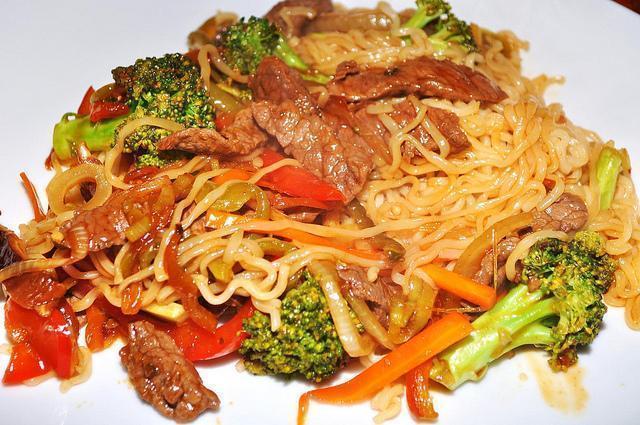What is touching the broccoli?
Choose the correct response, then elucidate: 'Answer: answer
Rationale: rationale.'
Options: Cats paw, pasta noodles, clowns nose, babys hand. Answer: pasta noodles.
Rationale: The other options make no sense and don't apply to a plate of food. 